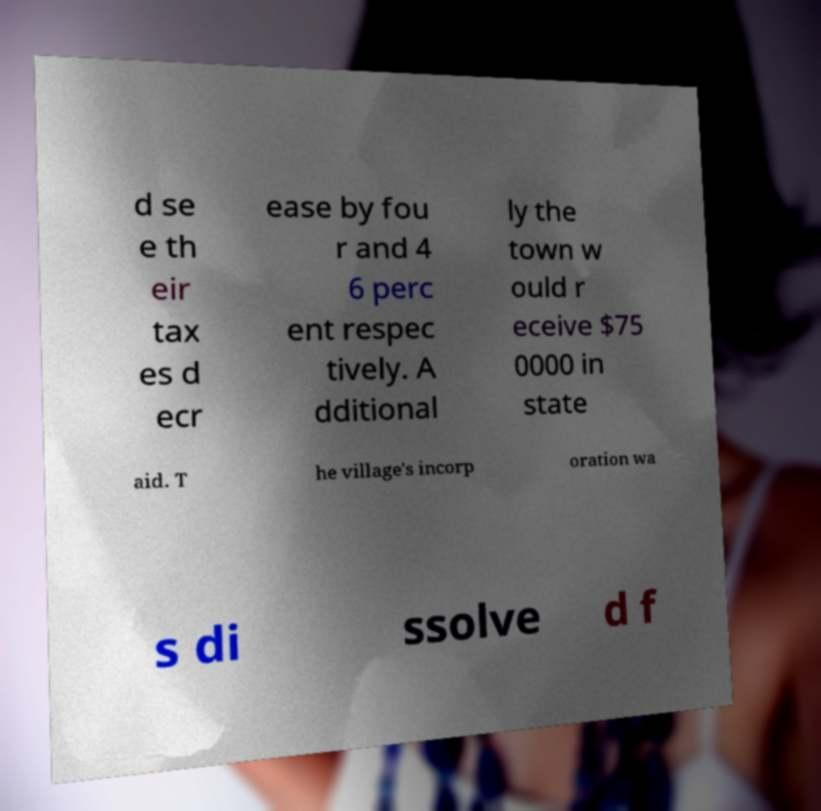What messages or text are displayed in this image? I need them in a readable, typed format. d se e th eir tax es d ecr ease by fou r and 4 6 perc ent respec tively. A dditional ly the town w ould r eceive $75 0000 in state aid. T he village's incorp oration wa s di ssolve d f 